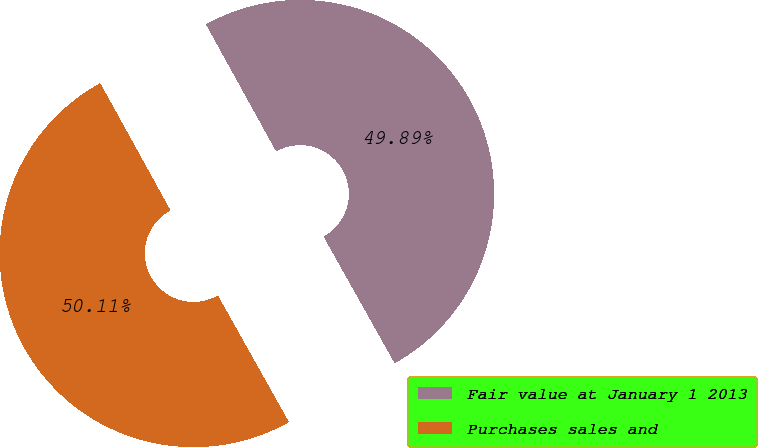<chart> <loc_0><loc_0><loc_500><loc_500><pie_chart><fcel>Fair value at January 1 2013<fcel>Purchases sales and<nl><fcel>49.89%<fcel>50.11%<nl></chart> 